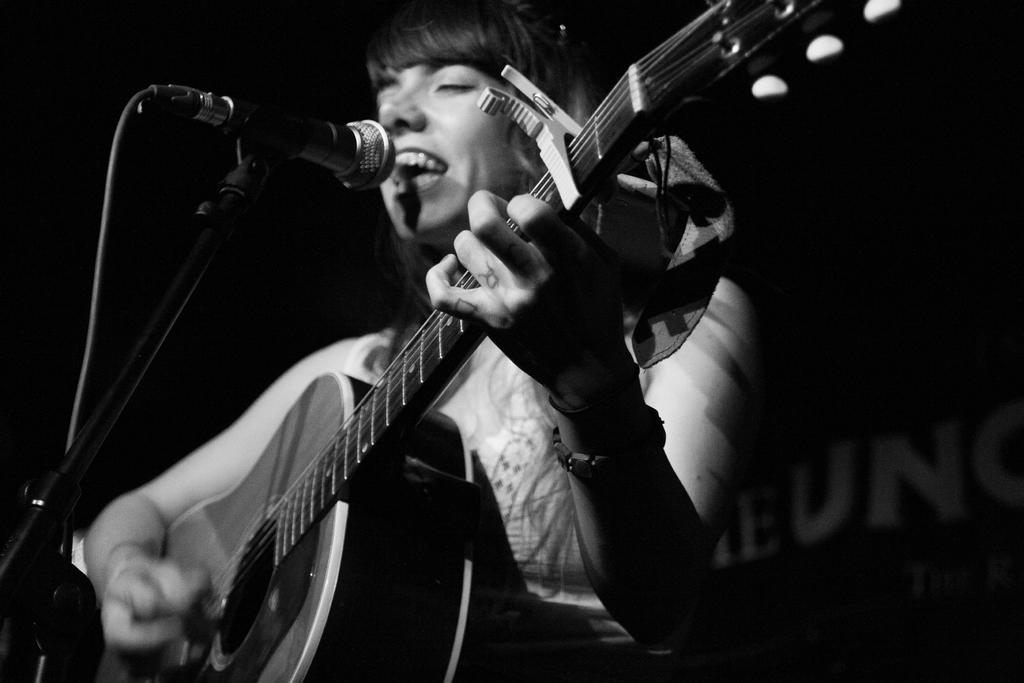Who is the main subject in the image? There is a woman in the image. What is the woman holding in the image? The woman is holding a guitar. What is the woman doing with the guitar? The woman is playing the guitar. What is the woman doing while playing the guitar? The woman is singing a song. What is in front of the woman that might be used for amplifying her voice? There is a microphone in front of the woman. What can be seen in the background of the image? There is a banner in the background of the image. What type of vessel is being used to hold the water in the image? There is no vessel or water present in the image; it features a woman playing a guitar and singing. 